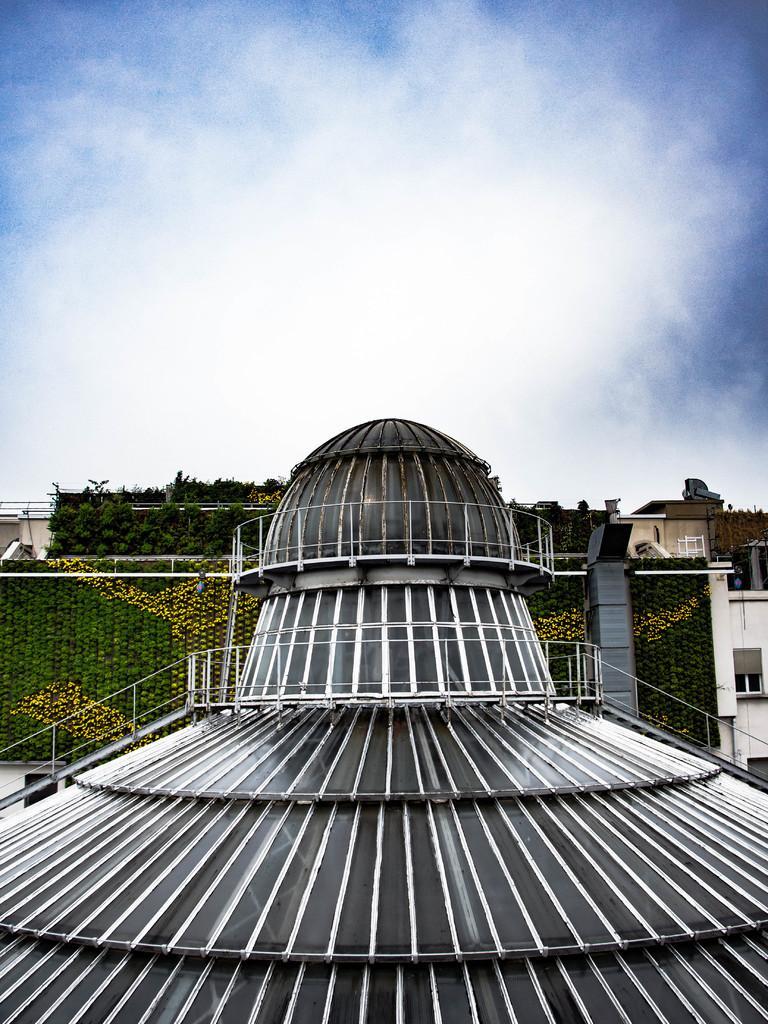How would you summarize this image in a sentence or two? In this image we can see the roof of an architecture, we can see buildings, plants and the sky with clouds in the background. 